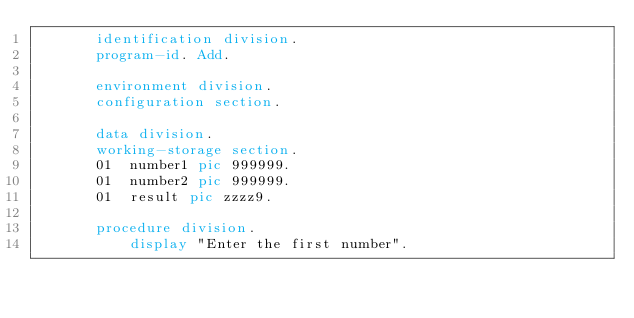<code> <loc_0><loc_0><loc_500><loc_500><_COBOL_>       identification division.
       program-id. Add.

       environment division.
       configuration section.

       data division.
       working-storage section.
       01  number1 pic 999999.
       01  number2 pic 999999.
       01  result pic zzzz9.

       procedure division.
           display "Enter the first number".</code> 